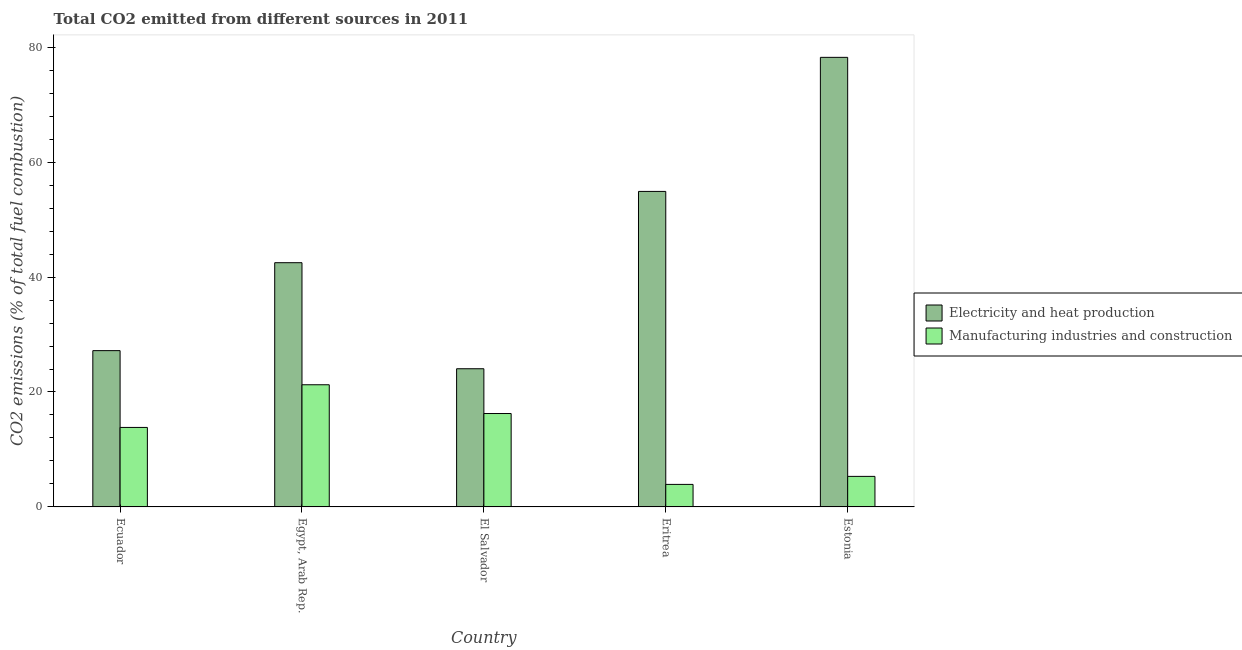How many different coloured bars are there?
Offer a terse response. 2. How many bars are there on the 4th tick from the right?
Your response must be concise. 2. What is the label of the 1st group of bars from the left?
Your answer should be compact. Ecuador. In how many cases, is the number of bars for a given country not equal to the number of legend labels?
Offer a very short reply. 0. What is the co2 emissions due to electricity and heat production in Ecuador?
Your response must be concise. 27.2. Across all countries, what is the maximum co2 emissions due to manufacturing industries?
Make the answer very short. 21.26. Across all countries, what is the minimum co2 emissions due to manufacturing industries?
Your response must be concise. 3.92. In which country was the co2 emissions due to electricity and heat production maximum?
Offer a terse response. Estonia. In which country was the co2 emissions due to manufacturing industries minimum?
Provide a succinct answer. Eritrea. What is the total co2 emissions due to electricity and heat production in the graph?
Make the answer very short. 226.87. What is the difference between the co2 emissions due to manufacturing industries in Ecuador and that in Estonia?
Your response must be concise. 8.52. What is the difference between the co2 emissions due to electricity and heat production in Ecuador and the co2 emissions due to manufacturing industries in Eritrea?
Offer a very short reply. 23.27. What is the average co2 emissions due to manufacturing industries per country?
Give a very brief answer. 12.12. What is the difference between the co2 emissions due to manufacturing industries and co2 emissions due to electricity and heat production in Ecuador?
Make the answer very short. -13.36. What is the ratio of the co2 emissions due to manufacturing industries in Ecuador to that in Estonia?
Keep it short and to the point. 2.6. Is the co2 emissions due to electricity and heat production in Egypt, Arab Rep. less than that in El Salvador?
Your response must be concise. No. What is the difference between the highest and the second highest co2 emissions due to manufacturing industries?
Make the answer very short. 5.01. What is the difference between the highest and the lowest co2 emissions due to electricity and heat production?
Provide a succinct answer. 54.18. In how many countries, is the co2 emissions due to electricity and heat production greater than the average co2 emissions due to electricity and heat production taken over all countries?
Give a very brief answer. 2. What does the 2nd bar from the left in Egypt, Arab Rep. represents?
Keep it short and to the point. Manufacturing industries and construction. What does the 1st bar from the right in Estonia represents?
Give a very brief answer. Manufacturing industries and construction. How many countries are there in the graph?
Provide a succinct answer. 5. What is the difference between two consecutive major ticks on the Y-axis?
Provide a succinct answer. 20. Are the values on the major ticks of Y-axis written in scientific E-notation?
Provide a succinct answer. No. Does the graph contain grids?
Ensure brevity in your answer.  No. Where does the legend appear in the graph?
Offer a terse response. Center right. How many legend labels are there?
Offer a terse response. 2. How are the legend labels stacked?
Your answer should be compact. Vertical. What is the title of the graph?
Offer a terse response. Total CO2 emitted from different sources in 2011. Does "Urban" appear as one of the legend labels in the graph?
Keep it short and to the point. No. What is the label or title of the Y-axis?
Provide a succinct answer. CO2 emissions (% of total fuel combustion). What is the CO2 emissions (% of total fuel combustion) in Electricity and heat production in Ecuador?
Make the answer very short. 27.2. What is the CO2 emissions (% of total fuel combustion) of Manufacturing industries and construction in Ecuador?
Give a very brief answer. 13.83. What is the CO2 emissions (% of total fuel combustion) of Electricity and heat production in Egypt, Arab Rep.?
Ensure brevity in your answer.  42.5. What is the CO2 emissions (% of total fuel combustion) in Manufacturing industries and construction in Egypt, Arab Rep.?
Ensure brevity in your answer.  21.26. What is the CO2 emissions (% of total fuel combustion) in Electricity and heat production in El Salvador?
Make the answer very short. 24.05. What is the CO2 emissions (% of total fuel combustion) of Manufacturing industries and construction in El Salvador?
Give a very brief answer. 16.25. What is the CO2 emissions (% of total fuel combustion) of Electricity and heat production in Eritrea?
Keep it short and to the point. 54.9. What is the CO2 emissions (% of total fuel combustion) in Manufacturing industries and construction in Eritrea?
Give a very brief answer. 3.92. What is the CO2 emissions (% of total fuel combustion) in Electricity and heat production in Estonia?
Ensure brevity in your answer.  78.23. What is the CO2 emissions (% of total fuel combustion) in Manufacturing industries and construction in Estonia?
Provide a short and direct response. 5.31. Across all countries, what is the maximum CO2 emissions (% of total fuel combustion) of Electricity and heat production?
Your answer should be very brief. 78.23. Across all countries, what is the maximum CO2 emissions (% of total fuel combustion) in Manufacturing industries and construction?
Give a very brief answer. 21.26. Across all countries, what is the minimum CO2 emissions (% of total fuel combustion) in Electricity and heat production?
Give a very brief answer. 24.05. Across all countries, what is the minimum CO2 emissions (% of total fuel combustion) in Manufacturing industries and construction?
Make the answer very short. 3.92. What is the total CO2 emissions (% of total fuel combustion) of Electricity and heat production in the graph?
Your answer should be very brief. 226.87. What is the total CO2 emissions (% of total fuel combustion) in Manufacturing industries and construction in the graph?
Offer a very short reply. 60.58. What is the difference between the CO2 emissions (% of total fuel combustion) of Electricity and heat production in Ecuador and that in Egypt, Arab Rep.?
Offer a very short reply. -15.3. What is the difference between the CO2 emissions (% of total fuel combustion) of Manufacturing industries and construction in Ecuador and that in Egypt, Arab Rep.?
Provide a succinct answer. -7.42. What is the difference between the CO2 emissions (% of total fuel combustion) in Electricity and heat production in Ecuador and that in El Salvador?
Your response must be concise. 3.15. What is the difference between the CO2 emissions (% of total fuel combustion) in Manufacturing industries and construction in Ecuador and that in El Salvador?
Offer a terse response. -2.42. What is the difference between the CO2 emissions (% of total fuel combustion) of Electricity and heat production in Ecuador and that in Eritrea?
Make the answer very short. -27.71. What is the difference between the CO2 emissions (% of total fuel combustion) of Manufacturing industries and construction in Ecuador and that in Eritrea?
Provide a short and direct response. 9.91. What is the difference between the CO2 emissions (% of total fuel combustion) of Electricity and heat production in Ecuador and that in Estonia?
Your answer should be very brief. -51.03. What is the difference between the CO2 emissions (% of total fuel combustion) in Manufacturing industries and construction in Ecuador and that in Estonia?
Your response must be concise. 8.52. What is the difference between the CO2 emissions (% of total fuel combustion) in Electricity and heat production in Egypt, Arab Rep. and that in El Salvador?
Offer a very short reply. 18.45. What is the difference between the CO2 emissions (% of total fuel combustion) of Manufacturing industries and construction in Egypt, Arab Rep. and that in El Salvador?
Make the answer very short. 5.01. What is the difference between the CO2 emissions (% of total fuel combustion) in Electricity and heat production in Egypt, Arab Rep. and that in Eritrea?
Ensure brevity in your answer.  -12.4. What is the difference between the CO2 emissions (% of total fuel combustion) in Manufacturing industries and construction in Egypt, Arab Rep. and that in Eritrea?
Offer a terse response. 17.34. What is the difference between the CO2 emissions (% of total fuel combustion) in Electricity and heat production in Egypt, Arab Rep. and that in Estonia?
Give a very brief answer. -35.73. What is the difference between the CO2 emissions (% of total fuel combustion) of Manufacturing industries and construction in Egypt, Arab Rep. and that in Estonia?
Ensure brevity in your answer.  15.94. What is the difference between the CO2 emissions (% of total fuel combustion) in Electricity and heat production in El Salvador and that in Eritrea?
Provide a succinct answer. -30.86. What is the difference between the CO2 emissions (% of total fuel combustion) of Manufacturing industries and construction in El Salvador and that in Eritrea?
Ensure brevity in your answer.  12.33. What is the difference between the CO2 emissions (% of total fuel combustion) of Electricity and heat production in El Salvador and that in Estonia?
Ensure brevity in your answer.  -54.18. What is the difference between the CO2 emissions (% of total fuel combustion) in Manufacturing industries and construction in El Salvador and that in Estonia?
Offer a terse response. 10.94. What is the difference between the CO2 emissions (% of total fuel combustion) in Electricity and heat production in Eritrea and that in Estonia?
Your answer should be compact. -23.33. What is the difference between the CO2 emissions (% of total fuel combustion) in Manufacturing industries and construction in Eritrea and that in Estonia?
Your response must be concise. -1.39. What is the difference between the CO2 emissions (% of total fuel combustion) of Electricity and heat production in Ecuador and the CO2 emissions (% of total fuel combustion) of Manufacturing industries and construction in Egypt, Arab Rep.?
Ensure brevity in your answer.  5.94. What is the difference between the CO2 emissions (% of total fuel combustion) in Electricity and heat production in Ecuador and the CO2 emissions (% of total fuel combustion) in Manufacturing industries and construction in El Salvador?
Offer a terse response. 10.94. What is the difference between the CO2 emissions (% of total fuel combustion) of Electricity and heat production in Ecuador and the CO2 emissions (% of total fuel combustion) of Manufacturing industries and construction in Eritrea?
Your answer should be compact. 23.27. What is the difference between the CO2 emissions (% of total fuel combustion) in Electricity and heat production in Ecuador and the CO2 emissions (% of total fuel combustion) in Manufacturing industries and construction in Estonia?
Offer a very short reply. 21.88. What is the difference between the CO2 emissions (% of total fuel combustion) of Electricity and heat production in Egypt, Arab Rep. and the CO2 emissions (% of total fuel combustion) of Manufacturing industries and construction in El Salvador?
Make the answer very short. 26.25. What is the difference between the CO2 emissions (% of total fuel combustion) of Electricity and heat production in Egypt, Arab Rep. and the CO2 emissions (% of total fuel combustion) of Manufacturing industries and construction in Eritrea?
Make the answer very short. 38.58. What is the difference between the CO2 emissions (% of total fuel combustion) in Electricity and heat production in Egypt, Arab Rep. and the CO2 emissions (% of total fuel combustion) in Manufacturing industries and construction in Estonia?
Your response must be concise. 37.18. What is the difference between the CO2 emissions (% of total fuel combustion) in Electricity and heat production in El Salvador and the CO2 emissions (% of total fuel combustion) in Manufacturing industries and construction in Eritrea?
Your answer should be very brief. 20.12. What is the difference between the CO2 emissions (% of total fuel combustion) of Electricity and heat production in El Salvador and the CO2 emissions (% of total fuel combustion) of Manufacturing industries and construction in Estonia?
Your response must be concise. 18.73. What is the difference between the CO2 emissions (% of total fuel combustion) in Electricity and heat production in Eritrea and the CO2 emissions (% of total fuel combustion) in Manufacturing industries and construction in Estonia?
Provide a succinct answer. 49.59. What is the average CO2 emissions (% of total fuel combustion) in Electricity and heat production per country?
Offer a very short reply. 45.37. What is the average CO2 emissions (% of total fuel combustion) in Manufacturing industries and construction per country?
Your answer should be very brief. 12.12. What is the difference between the CO2 emissions (% of total fuel combustion) in Electricity and heat production and CO2 emissions (% of total fuel combustion) in Manufacturing industries and construction in Ecuador?
Keep it short and to the point. 13.36. What is the difference between the CO2 emissions (% of total fuel combustion) in Electricity and heat production and CO2 emissions (% of total fuel combustion) in Manufacturing industries and construction in Egypt, Arab Rep.?
Ensure brevity in your answer.  21.24. What is the difference between the CO2 emissions (% of total fuel combustion) in Electricity and heat production and CO2 emissions (% of total fuel combustion) in Manufacturing industries and construction in El Salvador?
Your response must be concise. 7.79. What is the difference between the CO2 emissions (% of total fuel combustion) of Electricity and heat production and CO2 emissions (% of total fuel combustion) of Manufacturing industries and construction in Eritrea?
Make the answer very short. 50.98. What is the difference between the CO2 emissions (% of total fuel combustion) of Electricity and heat production and CO2 emissions (% of total fuel combustion) of Manufacturing industries and construction in Estonia?
Offer a very short reply. 72.91. What is the ratio of the CO2 emissions (% of total fuel combustion) of Electricity and heat production in Ecuador to that in Egypt, Arab Rep.?
Ensure brevity in your answer.  0.64. What is the ratio of the CO2 emissions (% of total fuel combustion) of Manufacturing industries and construction in Ecuador to that in Egypt, Arab Rep.?
Your response must be concise. 0.65. What is the ratio of the CO2 emissions (% of total fuel combustion) of Electricity and heat production in Ecuador to that in El Salvador?
Ensure brevity in your answer.  1.13. What is the ratio of the CO2 emissions (% of total fuel combustion) in Manufacturing industries and construction in Ecuador to that in El Salvador?
Make the answer very short. 0.85. What is the ratio of the CO2 emissions (% of total fuel combustion) of Electricity and heat production in Ecuador to that in Eritrea?
Your response must be concise. 0.5. What is the ratio of the CO2 emissions (% of total fuel combustion) of Manufacturing industries and construction in Ecuador to that in Eritrea?
Your answer should be compact. 3.53. What is the ratio of the CO2 emissions (% of total fuel combustion) in Electricity and heat production in Ecuador to that in Estonia?
Offer a very short reply. 0.35. What is the ratio of the CO2 emissions (% of total fuel combustion) in Manufacturing industries and construction in Ecuador to that in Estonia?
Keep it short and to the point. 2.6. What is the ratio of the CO2 emissions (% of total fuel combustion) in Electricity and heat production in Egypt, Arab Rep. to that in El Salvador?
Ensure brevity in your answer.  1.77. What is the ratio of the CO2 emissions (% of total fuel combustion) in Manufacturing industries and construction in Egypt, Arab Rep. to that in El Salvador?
Ensure brevity in your answer.  1.31. What is the ratio of the CO2 emissions (% of total fuel combustion) of Electricity and heat production in Egypt, Arab Rep. to that in Eritrea?
Your response must be concise. 0.77. What is the ratio of the CO2 emissions (% of total fuel combustion) in Manufacturing industries and construction in Egypt, Arab Rep. to that in Eritrea?
Your answer should be very brief. 5.42. What is the ratio of the CO2 emissions (% of total fuel combustion) of Electricity and heat production in Egypt, Arab Rep. to that in Estonia?
Offer a very short reply. 0.54. What is the ratio of the CO2 emissions (% of total fuel combustion) in Manufacturing industries and construction in Egypt, Arab Rep. to that in Estonia?
Ensure brevity in your answer.  4. What is the ratio of the CO2 emissions (% of total fuel combustion) of Electricity and heat production in El Salvador to that in Eritrea?
Make the answer very short. 0.44. What is the ratio of the CO2 emissions (% of total fuel combustion) of Manufacturing industries and construction in El Salvador to that in Eritrea?
Make the answer very short. 4.14. What is the ratio of the CO2 emissions (% of total fuel combustion) in Electricity and heat production in El Salvador to that in Estonia?
Give a very brief answer. 0.31. What is the ratio of the CO2 emissions (% of total fuel combustion) in Manufacturing industries and construction in El Salvador to that in Estonia?
Offer a terse response. 3.06. What is the ratio of the CO2 emissions (% of total fuel combustion) of Electricity and heat production in Eritrea to that in Estonia?
Your answer should be very brief. 0.7. What is the ratio of the CO2 emissions (% of total fuel combustion) of Manufacturing industries and construction in Eritrea to that in Estonia?
Offer a very short reply. 0.74. What is the difference between the highest and the second highest CO2 emissions (% of total fuel combustion) of Electricity and heat production?
Give a very brief answer. 23.33. What is the difference between the highest and the second highest CO2 emissions (% of total fuel combustion) in Manufacturing industries and construction?
Your answer should be compact. 5.01. What is the difference between the highest and the lowest CO2 emissions (% of total fuel combustion) in Electricity and heat production?
Your answer should be very brief. 54.18. What is the difference between the highest and the lowest CO2 emissions (% of total fuel combustion) of Manufacturing industries and construction?
Provide a short and direct response. 17.34. 